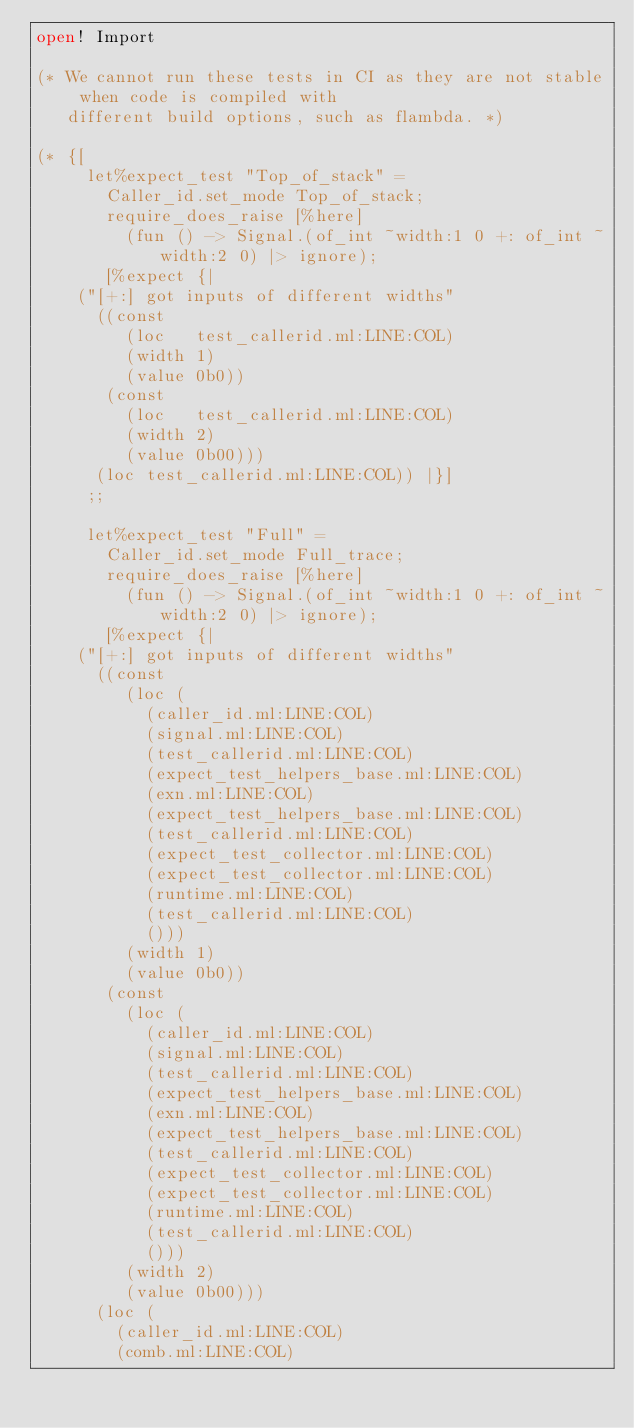<code> <loc_0><loc_0><loc_500><loc_500><_OCaml_>open! Import

(* We cannot run these tests in CI as they are not stable when code is compiled with
   different build options, such as flambda. *)

(* {[
     let%expect_test "Top_of_stack" =
       Caller_id.set_mode Top_of_stack;
       require_does_raise [%here]
         (fun () -> Signal.(of_int ~width:1 0 +: of_int ~width:2 0) |> ignore);
       [%expect {|
    ("[+:] got inputs of different widths"
      ((const
         (loc   test_callerid.ml:LINE:COL)
         (width 1)
         (value 0b0))
       (const
         (loc   test_callerid.ml:LINE:COL)
         (width 2)
         (value 0b00)))
      (loc test_callerid.ml:LINE:COL)) |}]
     ;;

     let%expect_test "Full" =
       Caller_id.set_mode Full_trace;
       require_does_raise [%here]
         (fun () -> Signal.(of_int ~width:1 0 +: of_int ~width:2 0) |> ignore);
       [%expect {|
    ("[+:] got inputs of different widths"
      ((const
         (loc (
           (caller_id.ml:LINE:COL)
           (signal.ml:LINE:COL)
           (test_callerid.ml:LINE:COL)
           (expect_test_helpers_base.ml:LINE:COL)
           (exn.ml:LINE:COL)
           (expect_test_helpers_base.ml:LINE:COL)
           (test_callerid.ml:LINE:COL)
           (expect_test_collector.ml:LINE:COL)
           (expect_test_collector.ml:LINE:COL)
           (runtime.ml:LINE:COL)
           (test_callerid.ml:LINE:COL)
           ()))
         (width 1)
         (value 0b0))
       (const
         (loc (
           (caller_id.ml:LINE:COL)
           (signal.ml:LINE:COL)
           (test_callerid.ml:LINE:COL)
           (expect_test_helpers_base.ml:LINE:COL)
           (exn.ml:LINE:COL)
           (expect_test_helpers_base.ml:LINE:COL)
           (test_callerid.ml:LINE:COL)
           (expect_test_collector.ml:LINE:COL)
           (expect_test_collector.ml:LINE:COL)
           (runtime.ml:LINE:COL)
           (test_callerid.ml:LINE:COL)
           ()))
         (width 2)
         (value 0b00)))
      (loc (
        (caller_id.ml:LINE:COL)
        (comb.ml:LINE:COL)</code> 